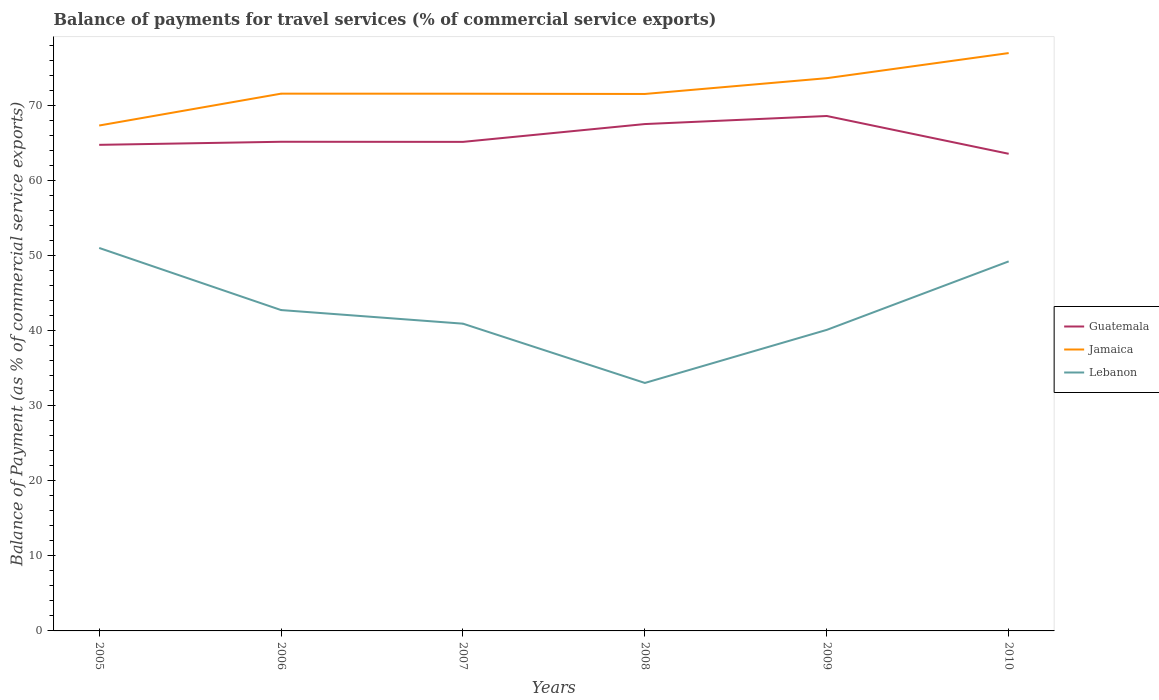Does the line corresponding to Lebanon intersect with the line corresponding to Jamaica?
Your answer should be compact. No. Across all years, what is the maximum balance of payments for travel services in Lebanon?
Your answer should be very brief. 33.03. In which year was the balance of payments for travel services in Lebanon maximum?
Give a very brief answer. 2008. What is the total balance of payments for travel services in Lebanon in the graph?
Make the answer very short. -16.19. What is the difference between the highest and the second highest balance of payments for travel services in Guatemala?
Ensure brevity in your answer.  5.03. What is the difference between the highest and the lowest balance of payments for travel services in Lebanon?
Give a very brief answer. 2. How many lines are there?
Ensure brevity in your answer.  3. How many years are there in the graph?
Your answer should be very brief. 6. Are the values on the major ticks of Y-axis written in scientific E-notation?
Your answer should be very brief. No. Does the graph contain any zero values?
Make the answer very short. No. Does the graph contain grids?
Keep it short and to the point. No. How many legend labels are there?
Provide a succinct answer. 3. What is the title of the graph?
Offer a terse response. Balance of payments for travel services (% of commercial service exports). Does "Puerto Rico" appear as one of the legend labels in the graph?
Your response must be concise. No. What is the label or title of the Y-axis?
Your answer should be very brief. Balance of Payment (as % of commercial service exports). What is the Balance of Payment (as % of commercial service exports) of Guatemala in 2005?
Provide a short and direct response. 64.74. What is the Balance of Payment (as % of commercial service exports) in Jamaica in 2005?
Your answer should be compact. 67.31. What is the Balance of Payment (as % of commercial service exports) in Lebanon in 2005?
Make the answer very short. 51. What is the Balance of Payment (as % of commercial service exports) in Guatemala in 2006?
Keep it short and to the point. 65.15. What is the Balance of Payment (as % of commercial service exports) in Jamaica in 2006?
Provide a short and direct response. 71.55. What is the Balance of Payment (as % of commercial service exports) of Lebanon in 2006?
Your answer should be very brief. 42.73. What is the Balance of Payment (as % of commercial service exports) of Guatemala in 2007?
Provide a succinct answer. 65.13. What is the Balance of Payment (as % of commercial service exports) of Jamaica in 2007?
Give a very brief answer. 71.55. What is the Balance of Payment (as % of commercial service exports) in Lebanon in 2007?
Your answer should be compact. 40.92. What is the Balance of Payment (as % of commercial service exports) in Guatemala in 2008?
Your response must be concise. 67.51. What is the Balance of Payment (as % of commercial service exports) of Jamaica in 2008?
Give a very brief answer. 71.51. What is the Balance of Payment (as % of commercial service exports) in Lebanon in 2008?
Make the answer very short. 33.03. What is the Balance of Payment (as % of commercial service exports) of Guatemala in 2009?
Offer a terse response. 68.58. What is the Balance of Payment (as % of commercial service exports) of Jamaica in 2009?
Your answer should be compact. 73.62. What is the Balance of Payment (as % of commercial service exports) in Lebanon in 2009?
Provide a succinct answer. 40.09. What is the Balance of Payment (as % of commercial service exports) in Guatemala in 2010?
Make the answer very short. 63.55. What is the Balance of Payment (as % of commercial service exports) in Jamaica in 2010?
Ensure brevity in your answer.  76.96. What is the Balance of Payment (as % of commercial service exports) of Lebanon in 2010?
Provide a succinct answer. 49.22. Across all years, what is the maximum Balance of Payment (as % of commercial service exports) in Guatemala?
Provide a succinct answer. 68.58. Across all years, what is the maximum Balance of Payment (as % of commercial service exports) in Jamaica?
Keep it short and to the point. 76.96. Across all years, what is the maximum Balance of Payment (as % of commercial service exports) of Lebanon?
Offer a very short reply. 51. Across all years, what is the minimum Balance of Payment (as % of commercial service exports) of Guatemala?
Your response must be concise. 63.55. Across all years, what is the minimum Balance of Payment (as % of commercial service exports) in Jamaica?
Your answer should be very brief. 67.31. Across all years, what is the minimum Balance of Payment (as % of commercial service exports) in Lebanon?
Offer a very short reply. 33.03. What is the total Balance of Payment (as % of commercial service exports) of Guatemala in the graph?
Ensure brevity in your answer.  394.65. What is the total Balance of Payment (as % of commercial service exports) in Jamaica in the graph?
Offer a very short reply. 432.5. What is the total Balance of Payment (as % of commercial service exports) in Lebanon in the graph?
Offer a very short reply. 256.99. What is the difference between the Balance of Payment (as % of commercial service exports) of Guatemala in 2005 and that in 2006?
Keep it short and to the point. -0.41. What is the difference between the Balance of Payment (as % of commercial service exports) in Jamaica in 2005 and that in 2006?
Give a very brief answer. -4.24. What is the difference between the Balance of Payment (as % of commercial service exports) of Lebanon in 2005 and that in 2006?
Make the answer very short. 8.27. What is the difference between the Balance of Payment (as % of commercial service exports) of Guatemala in 2005 and that in 2007?
Make the answer very short. -0.4. What is the difference between the Balance of Payment (as % of commercial service exports) in Jamaica in 2005 and that in 2007?
Your response must be concise. -4.24. What is the difference between the Balance of Payment (as % of commercial service exports) of Lebanon in 2005 and that in 2007?
Keep it short and to the point. 10.09. What is the difference between the Balance of Payment (as % of commercial service exports) of Guatemala in 2005 and that in 2008?
Provide a short and direct response. -2.77. What is the difference between the Balance of Payment (as % of commercial service exports) in Jamaica in 2005 and that in 2008?
Provide a short and direct response. -4.2. What is the difference between the Balance of Payment (as % of commercial service exports) of Lebanon in 2005 and that in 2008?
Give a very brief answer. 17.98. What is the difference between the Balance of Payment (as % of commercial service exports) in Guatemala in 2005 and that in 2009?
Provide a short and direct response. -3.84. What is the difference between the Balance of Payment (as % of commercial service exports) in Jamaica in 2005 and that in 2009?
Give a very brief answer. -6.31. What is the difference between the Balance of Payment (as % of commercial service exports) of Lebanon in 2005 and that in 2009?
Provide a short and direct response. 10.91. What is the difference between the Balance of Payment (as % of commercial service exports) of Guatemala in 2005 and that in 2010?
Keep it short and to the point. 1.19. What is the difference between the Balance of Payment (as % of commercial service exports) of Jamaica in 2005 and that in 2010?
Provide a succinct answer. -9.65. What is the difference between the Balance of Payment (as % of commercial service exports) of Lebanon in 2005 and that in 2010?
Make the answer very short. 1.79. What is the difference between the Balance of Payment (as % of commercial service exports) in Guatemala in 2006 and that in 2007?
Provide a succinct answer. 0.01. What is the difference between the Balance of Payment (as % of commercial service exports) of Jamaica in 2006 and that in 2007?
Keep it short and to the point. 0.01. What is the difference between the Balance of Payment (as % of commercial service exports) of Lebanon in 2006 and that in 2007?
Provide a short and direct response. 1.81. What is the difference between the Balance of Payment (as % of commercial service exports) in Guatemala in 2006 and that in 2008?
Your answer should be compact. -2.36. What is the difference between the Balance of Payment (as % of commercial service exports) in Jamaica in 2006 and that in 2008?
Keep it short and to the point. 0.04. What is the difference between the Balance of Payment (as % of commercial service exports) in Lebanon in 2006 and that in 2008?
Offer a terse response. 9.71. What is the difference between the Balance of Payment (as % of commercial service exports) of Guatemala in 2006 and that in 2009?
Ensure brevity in your answer.  -3.43. What is the difference between the Balance of Payment (as % of commercial service exports) in Jamaica in 2006 and that in 2009?
Offer a very short reply. -2.06. What is the difference between the Balance of Payment (as % of commercial service exports) in Lebanon in 2006 and that in 2009?
Your response must be concise. 2.64. What is the difference between the Balance of Payment (as % of commercial service exports) in Guatemala in 2006 and that in 2010?
Ensure brevity in your answer.  1.6. What is the difference between the Balance of Payment (as % of commercial service exports) of Jamaica in 2006 and that in 2010?
Your answer should be compact. -5.41. What is the difference between the Balance of Payment (as % of commercial service exports) in Lebanon in 2006 and that in 2010?
Offer a very short reply. -6.48. What is the difference between the Balance of Payment (as % of commercial service exports) in Guatemala in 2007 and that in 2008?
Provide a succinct answer. -2.37. What is the difference between the Balance of Payment (as % of commercial service exports) of Jamaica in 2007 and that in 2008?
Give a very brief answer. 0.03. What is the difference between the Balance of Payment (as % of commercial service exports) in Lebanon in 2007 and that in 2008?
Offer a very short reply. 7.89. What is the difference between the Balance of Payment (as % of commercial service exports) in Guatemala in 2007 and that in 2009?
Ensure brevity in your answer.  -3.45. What is the difference between the Balance of Payment (as % of commercial service exports) of Jamaica in 2007 and that in 2009?
Your answer should be very brief. -2.07. What is the difference between the Balance of Payment (as % of commercial service exports) of Lebanon in 2007 and that in 2009?
Keep it short and to the point. 0.83. What is the difference between the Balance of Payment (as % of commercial service exports) of Guatemala in 2007 and that in 2010?
Offer a very short reply. 1.59. What is the difference between the Balance of Payment (as % of commercial service exports) of Jamaica in 2007 and that in 2010?
Keep it short and to the point. -5.41. What is the difference between the Balance of Payment (as % of commercial service exports) of Lebanon in 2007 and that in 2010?
Your response must be concise. -8.3. What is the difference between the Balance of Payment (as % of commercial service exports) of Guatemala in 2008 and that in 2009?
Give a very brief answer. -1.07. What is the difference between the Balance of Payment (as % of commercial service exports) of Jamaica in 2008 and that in 2009?
Ensure brevity in your answer.  -2.1. What is the difference between the Balance of Payment (as % of commercial service exports) of Lebanon in 2008 and that in 2009?
Give a very brief answer. -7.07. What is the difference between the Balance of Payment (as % of commercial service exports) of Guatemala in 2008 and that in 2010?
Give a very brief answer. 3.96. What is the difference between the Balance of Payment (as % of commercial service exports) in Jamaica in 2008 and that in 2010?
Keep it short and to the point. -5.45. What is the difference between the Balance of Payment (as % of commercial service exports) in Lebanon in 2008 and that in 2010?
Your answer should be very brief. -16.19. What is the difference between the Balance of Payment (as % of commercial service exports) in Guatemala in 2009 and that in 2010?
Your response must be concise. 5.03. What is the difference between the Balance of Payment (as % of commercial service exports) of Jamaica in 2009 and that in 2010?
Your response must be concise. -3.34. What is the difference between the Balance of Payment (as % of commercial service exports) of Lebanon in 2009 and that in 2010?
Give a very brief answer. -9.12. What is the difference between the Balance of Payment (as % of commercial service exports) in Guatemala in 2005 and the Balance of Payment (as % of commercial service exports) in Jamaica in 2006?
Ensure brevity in your answer.  -6.82. What is the difference between the Balance of Payment (as % of commercial service exports) in Guatemala in 2005 and the Balance of Payment (as % of commercial service exports) in Lebanon in 2006?
Ensure brevity in your answer.  22. What is the difference between the Balance of Payment (as % of commercial service exports) of Jamaica in 2005 and the Balance of Payment (as % of commercial service exports) of Lebanon in 2006?
Keep it short and to the point. 24.58. What is the difference between the Balance of Payment (as % of commercial service exports) in Guatemala in 2005 and the Balance of Payment (as % of commercial service exports) in Jamaica in 2007?
Give a very brief answer. -6.81. What is the difference between the Balance of Payment (as % of commercial service exports) in Guatemala in 2005 and the Balance of Payment (as % of commercial service exports) in Lebanon in 2007?
Provide a succinct answer. 23.82. What is the difference between the Balance of Payment (as % of commercial service exports) in Jamaica in 2005 and the Balance of Payment (as % of commercial service exports) in Lebanon in 2007?
Give a very brief answer. 26.39. What is the difference between the Balance of Payment (as % of commercial service exports) in Guatemala in 2005 and the Balance of Payment (as % of commercial service exports) in Jamaica in 2008?
Provide a succinct answer. -6.78. What is the difference between the Balance of Payment (as % of commercial service exports) in Guatemala in 2005 and the Balance of Payment (as % of commercial service exports) in Lebanon in 2008?
Give a very brief answer. 31.71. What is the difference between the Balance of Payment (as % of commercial service exports) in Jamaica in 2005 and the Balance of Payment (as % of commercial service exports) in Lebanon in 2008?
Offer a very short reply. 34.29. What is the difference between the Balance of Payment (as % of commercial service exports) of Guatemala in 2005 and the Balance of Payment (as % of commercial service exports) of Jamaica in 2009?
Offer a terse response. -8.88. What is the difference between the Balance of Payment (as % of commercial service exports) in Guatemala in 2005 and the Balance of Payment (as % of commercial service exports) in Lebanon in 2009?
Keep it short and to the point. 24.64. What is the difference between the Balance of Payment (as % of commercial service exports) in Jamaica in 2005 and the Balance of Payment (as % of commercial service exports) in Lebanon in 2009?
Keep it short and to the point. 27.22. What is the difference between the Balance of Payment (as % of commercial service exports) in Guatemala in 2005 and the Balance of Payment (as % of commercial service exports) in Jamaica in 2010?
Provide a succinct answer. -12.22. What is the difference between the Balance of Payment (as % of commercial service exports) of Guatemala in 2005 and the Balance of Payment (as % of commercial service exports) of Lebanon in 2010?
Offer a very short reply. 15.52. What is the difference between the Balance of Payment (as % of commercial service exports) in Jamaica in 2005 and the Balance of Payment (as % of commercial service exports) in Lebanon in 2010?
Keep it short and to the point. 18.09. What is the difference between the Balance of Payment (as % of commercial service exports) of Guatemala in 2006 and the Balance of Payment (as % of commercial service exports) of Jamaica in 2007?
Give a very brief answer. -6.4. What is the difference between the Balance of Payment (as % of commercial service exports) in Guatemala in 2006 and the Balance of Payment (as % of commercial service exports) in Lebanon in 2007?
Make the answer very short. 24.23. What is the difference between the Balance of Payment (as % of commercial service exports) in Jamaica in 2006 and the Balance of Payment (as % of commercial service exports) in Lebanon in 2007?
Ensure brevity in your answer.  30.63. What is the difference between the Balance of Payment (as % of commercial service exports) in Guatemala in 2006 and the Balance of Payment (as % of commercial service exports) in Jamaica in 2008?
Provide a succinct answer. -6.37. What is the difference between the Balance of Payment (as % of commercial service exports) in Guatemala in 2006 and the Balance of Payment (as % of commercial service exports) in Lebanon in 2008?
Give a very brief answer. 32.12. What is the difference between the Balance of Payment (as % of commercial service exports) of Jamaica in 2006 and the Balance of Payment (as % of commercial service exports) of Lebanon in 2008?
Make the answer very short. 38.53. What is the difference between the Balance of Payment (as % of commercial service exports) of Guatemala in 2006 and the Balance of Payment (as % of commercial service exports) of Jamaica in 2009?
Give a very brief answer. -8.47. What is the difference between the Balance of Payment (as % of commercial service exports) in Guatemala in 2006 and the Balance of Payment (as % of commercial service exports) in Lebanon in 2009?
Offer a terse response. 25.05. What is the difference between the Balance of Payment (as % of commercial service exports) of Jamaica in 2006 and the Balance of Payment (as % of commercial service exports) of Lebanon in 2009?
Offer a very short reply. 31.46. What is the difference between the Balance of Payment (as % of commercial service exports) of Guatemala in 2006 and the Balance of Payment (as % of commercial service exports) of Jamaica in 2010?
Your answer should be compact. -11.81. What is the difference between the Balance of Payment (as % of commercial service exports) of Guatemala in 2006 and the Balance of Payment (as % of commercial service exports) of Lebanon in 2010?
Provide a short and direct response. 15.93. What is the difference between the Balance of Payment (as % of commercial service exports) in Jamaica in 2006 and the Balance of Payment (as % of commercial service exports) in Lebanon in 2010?
Make the answer very short. 22.34. What is the difference between the Balance of Payment (as % of commercial service exports) of Guatemala in 2007 and the Balance of Payment (as % of commercial service exports) of Jamaica in 2008?
Keep it short and to the point. -6.38. What is the difference between the Balance of Payment (as % of commercial service exports) of Guatemala in 2007 and the Balance of Payment (as % of commercial service exports) of Lebanon in 2008?
Provide a succinct answer. 32.11. What is the difference between the Balance of Payment (as % of commercial service exports) of Jamaica in 2007 and the Balance of Payment (as % of commercial service exports) of Lebanon in 2008?
Offer a terse response. 38.52. What is the difference between the Balance of Payment (as % of commercial service exports) of Guatemala in 2007 and the Balance of Payment (as % of commercial service exports) of Jamaica in 2009?
Your answer should be very brief. -8.48. What is the difference between the Balance of Payment (as % of commercial service exports) in Guatemala in 2007 and the Balance of Payment (as % of commercial service exports) in Lebanon in 2009?
Your answer should be compact. 25.04. What is the difference between the Balance of Payment (as % of commercial service exports) in Jamaica in 2007 and the Balance of Payment (as % of commercial service exports) in Lebanon in 2009?
Make the answer very short. 31.45. What is the difference between the Balance of Payment (as % of commercial service exports) in Guatemala in 2007 and the Balance of Payment (as % of commercial service exports) in Jamaica in 2010?
Provide a succinct answer. -11.83. What is the difference between the Balance of Payment (as % of commercial service exports) in Guatemala in 2007 and the Balance of Payment (as % of commercial service exports) in Lebanon in 2010?
Give a very brief answer. 15.92. What is the difference between the Balance of Payment (as % of commercial service exports) in Jamaica in 2007 and the Balance of Payment (as % of commercial service exports) in Lebanon in 2010?
Your response must be concise. 22.33. What is the difference between the Balance of Payment (as % of commercial service exports) of Guatemala in 2008 and the Balance of Payment (as % of commercial service exports) of Jamaica in 2009?
Provide a succinct answer. -6.11. What is the difference between the Balance of Payment (as % of commercial service exports) of Guatemala in 2008 and the Balance of Payment (as % of commercial service exports) of Lebanon in 2009?
Provide a short and direct response. 27.41. What is the difference between the Balance of Payment (as % of commercial service exports) of Jamaica in 2008 and the Balance of Payment (as % of commercial service exports) of Lebanon in 2009?
Offer a terse response. 31.42. What is the difference between the Balance of Payment (as % of commercial service exports) of Guatemala in 2008 and the Balance of Payment (as % of commercial service exports) of Jamaica in 2010?
Offer a very short reply. -9.45. What is the difference between the Balance of Payment (as % of commercial service exports) in Guatemala in 2008 and the Balance of Payment (as % of commercial service exports) in Lebanon in 2010?
Keep it short and to the point. 18.29. What is the difference between the Balance of Payment (as % of commercial service exports) in Jamaica in 2008 and the Balance of Payment (as % of commercial service exports) in Lebanon in 2010?
Your response must be concise. 22.3. What is the difference between the Balance of Payment (as % of commercial service exports) in Guatemala in 2009 and the Balance of Payment (as % of commercial service exports) in Jamaica in 2010?
Your response must be concise. -8.38. What is the difference between the Balance of Payment (as % of commercial service exports) in Guatemala in 2009 and the Balance of Payment (as % of commercial service exports) in Lebanon in 2010?
Keep it short and to the point. 19.36. What is the difference between the Balance of Payment (as % of commercial service exports) in Jamaica in 2009 and the Balance of Payment (as % of commercial service exports) in Lebanon in 2010?
Offer a terse response. 24.4. What is the average Balance of Payment (as % of commercial service exports) in Guatemala per year?
Keep it short and to the point. 65.78. What is the average Balance of Payment (as % of commercial service exports) of Jamaica per year?
Keep it short and to the point. 72.08. What is the average Balance of Payment (as % of commercial service exports) in Lebanon per year?
Give a very brief answer. 42.83. In the year 2005, what is the difference between the Balance of Payment (as % of commercial service exports) in Guatemala and Balance of Payment (as % of commercial service exports) in Jamaica?
Keep it short and to the point. -2.57. In the year 2005, what is the difference between the Balance of Payment (as % of commercial service exports) in Guatemala and Balance of Payment (as % of commercial service exports) in Lebanon?
Provide a short and direct response. 13.73. In the year 2005, what is the difference between the Balance of Payment (as % of commercial service exports) in Jamaica and Balance of Payment (as % of commercial service exports) in Lebanon?
Give a very brief answer. 16.31. In the year 2006, what is the difference between the Balance of Payment (as % of commercial service exports) of Guatemala and Balance of Payment (as % of commercial service exports) of Jamaica?
Your response must be concise. -6.41. In the year 2006, what is the difference between the Balance of Payment (as % of commercial service exports) in Guatemala and Balance of Payment (as % of commercial service exports) in Lebanon?
Provide a succinct answer. 22.41. In the year 2006, what is the difference between the Balance of Payment (as % of commercial service exports) in Jamaica and Balance of Payment (as % of commercial service exports) in Lebanon?
Give a very brief answer. 28.82. In the year 2007, what is the difference between the Balance of Payment (as % of commercial service exports) of Guatemala and Balance of Payment (as % of commercial service exports) of Jamaica?
Offer a terse response. -6.42. In the year 2007, what is the difference between the Balance of Payment (as % of commercial service exports) in Guatemala and Balance of Payment (as % of commercial service exports) in Lebanon?
Your answer should be very brief. 24.21. In the year 2007, what is the difference between the Balance of Payment (as % of commercial service exports) in Jamaica and Balance of Payment (as % of commercial service exports) in Lebanon?
Keep it short and to the point. 30.63. In the year 2008, what is the difference between the Balance of Payment (as % of commercial service exports) of Guatemala and Balance of Payment (as % of commercial service exports) of Jamaica?
Offer a terse response. -4.01. In the year 2008, what is the difference between the Balance of Payment (as % of commercial service exports) in Guatemala and Balance of Payment (as % of commercial service exports) in Lebanon?
Ensure brevity in your answer.  34.48. In the year 2008, what is the difference between the Balance of Payment (as % of commercial service exports) in Jamaica and Balance of Payment (as % of commercial service exports) in Lebanon?
Your response must be concise. 38.49. In the year 2009, what is the difference between the Balance of Payment (as % of commercial service exports) in Guatemala and Balance of Payment (as % of commercial service exports) in Jamaica?
Keep it short and to the point. -5.04. In the year 2009, what is the difference between the Balance of Payment (as % of commercial service exports) in Guatemala and Balance of Payment (as % of commercial service exports) in Lebanon?
Keep it short and to the point. 28.48. In the year 2009, what is the difference between the Balance of Payment (as % of commercial service exports) of Jamaica and Balance of Payment (as % of commercial service exports) of Lebanon?
Offer a very short reply. 33.52. In the year 2010, what is the difference between the Balance of Payment (as % of commercial service exports) in Guatemala and Balance of Payment (as % of commercial service exports) in Jamaica?
Make the answer very short. -13.41. In the year 2010, what is the difference between the Balance of Payment (as % of commercial service exports) in Guatemala and Balance of Payment (as % of commercial service exports) in Lebanon?
Make the answer very short. 14.33. In the year 2010, what is the difference between the Balance of Payment (as % of commercial service exports) of Jamaica and Balance of Payment (as % of commercial service exports) of Lebanon?
Your answer should be compact. 27.74. What is the ratio of the Balance of Payment (as % of commercial service exports) of Jamaica in 2005 to that in 2006?
Provide a succinct answer. 0.94. What is the ratio of the Balance of Payment (as % of commercial service exports) in Lebanon in 2005 to that in 2006?
Keep it short and to the point. 1.19. What is the ratio of the Balance of Payment (as % of commercial service exports) of Jamaica in 2005 to that in 2007?
Make the answer very short. 0.94. What is the ratio of the Balance of Payment (as % of commercial service exports) in Lebanon in 2005 to that in 2007?
Provide a succinct answer. 1.25. What is the ratio of the Balance of Payment (as % of commercial service exports) of Lebanon in 2005 to that in 2008?
Your response must be concise. 1.54. What is the ratio of the Balance of Payment (as % of commercial service exports) of Guatemala in 2005 to that in 2009?
Your response must be concise. 0.94. What is the ratio of the Balance of Payment (as % of commercial service exports) of Jamaica in 2005 to that in 2009?
Make the answer very short. 0.91. What is the ratio of the Balance of Payment (as % of commercial service exports) of Lebanon in 2005 to that in 2009?
Provide a succinct answer. 1.27. What is the ratio of the Balance of Payment (as % of commercial service exports) in Guatemala in 2005 to that in 2010?
Offer a terse response. 1.02. What is the ratio of the Balance of Payment (as % of commercial service exports) of Jamaica in 2005 to that in 2010?
Give a very brief answer. 0.87. What is the ratio of the Balance of Payment (as % of commercial service exports) of Lebanon in 2005 to that in 2010?
Keep it short and to the point. 1.04. What is the ratio of the Balance of Payment (as % of commercial service exports) in Guatemala in 2006 to that in 2007?
Offer a very short reply. 1. What is the ratio of the Balance of Payment (as % of commercial service exports) in Jamaica in 2006 to that in 2007?
Provide a succinct answer. 1. What is the ratio of the Balance of Payment (as % of commercial service exports) in Lebanon in 2006 to that in 2007?
Offer a very short reply. 1.04. What is the ratio of the Balance of Payment (as % of commercial service exports) in Guatemala in 2006 to that in 2008?
Provide a succinct answer. 0.97. What is the ratio of the Balance of Payment (as % of commercial service exports) of Jamaica in 2006 to that in 2008?
Offer a very short reply. 1. What is the ratio of the Balance of Payment (as % of commercial service exports) of Lebanon in 2006 to that in 2008?
Give a very brief answer. 1.29. What is the ratio of the Balance of Payment (as % of commercial service exports) of Guatemala in 2006 to that in 2009?
Provide a short and direct response. 0.95. What is the ratio of the Balance of Payment (as % of commercial service exports) of Jamaica in 2006 to that in 2009?
Provide a succinct answer. 0.97. What is the ratio of the Balance of Payment (as % of commercial service exports) of Lebanon in 2006 to that in 2009?
Provide a short and direct response. 1.07. What is the ratio of the Balance of Payment (as % of commercial service exports) of Guatemala in 2006 to that in 2010?
Provide a succinct answer. 1.03. What is the ratio of the Balance of Payment (as % of commercial service exports) in Jamaica in 2006 to that in 2010?
Your response must be concise. 0.93. What is the ratio of the Balance of Payment (as % of commercial service exports) in Lebanon in 2006 to that in 2010?
Your answer should be compact. 0.87. What is the ratio of the Balance of Payment (as % of commercial service exports) in Guatemala in 2007 to that in 2008?
Provide a short and direct response. 0.96. What is the ratio of the Balance of Payment (as % of commercial service exports) of Lebanon in 2007 to that in 2008?
Ensure brevity in your answer.  1.24. What is the ratio of the Balance of Payment (as % of commercial service exports) in Guatemala in 2007 to that in 2009?
Give a very brief answer. 0.95. What is the ratio of the Balance of Payment (as % of commercial service exports) in Jamaica in 2007 to that in 2009?
Offer a terse response. 0.97. What is the ratio of the Balance of Payment (as % of commercial service exports) in Lebanon in 2007 to that in 2009?
Give a very brief answer. 1.02. What is the ratio of the Balance of Payment (as % of commercial service exports) of Jamaica in 2007 to that in 2010?
Your answer should be very brief. 0.93. What is the ratio of the Balance of Payment (as % of commercial service exports) in Lebanon in 2007 to that in 2010?
Give a very brief answer. 0.83. What is the ratio of the Balance of Payment (as % of commercial service exports) of Guatemala in 2008 to that in 2009?
Your response must be concise. 0.98. What is the ratio of the Balance of Payment (as % of commercial service exports) of Jamaica in 2008 to that in 2009?
Your answer should be very brief. 0.97. What is the ratio of the Balance of Payment (as % of commercial service exports) in Lebanon in 2008 to that in 2009?
Your answer should be compact. 0.82. What is the ratio of the Balance of Payment (as % of commercial service exports) in Guatemala in 2008 to that in 2010?
Make the answer very short. 1.06. What is the ratio of the Balance of Payment (as % of commercial service exports) of Jamaica in 2008 to that in 2010?
Provide a short and direct response. 0.93. What is the ratio of the Balance of Payment (as % of commercial service exports) in Lebanon in 2008 to that in 2010?
Your answer should be very brief. 0.67. What is the ratio of the Balance of Payment (as % of commercial service exports) in Guatemala in 2009 to that in 2010?
Your answer should be very brief. 1.08. What is the ratio of the Balance of Payment (as % of commercial service exports) of Jamaica in 2009 to that in 2010?
Offer a terse response. 0.96. What is the ratio of the Balance of Payment (as % of commercial service exports) in Lebanon in 2009 to that in 2010?
Offer a terse response. 0.81. What is the difference between the highest and the second highest Balance of Payment (as % of commercial service exports) in Guatemala?
Ensure brevity in your answer.  1.07. What is the difference between the highest and the second highest Balance of Payment (as % of commercial service exports) of Jamaica?
Keep it short and to the point. 3.34. What is the difference between the highest and the second highest Balance of Payment (as % of commercial service exports) in Lebanon?
Keep it short and to the point. 1.79. What is the difference between the highest and the lowest Balance of Payment (as % of commercial service exports) of Guatemala?
Provide a succinct answer. 5.03. What is the difference between the highest and the lowest Balance of Payment (as % of commercial service exports) of Jamaica?
Give a very brief answer. 9.65. What is the difference between the highest and the lowest Balance of Payment (as % of commercial service exports) in Lebanon?
Make the answer very short. 17.98. 